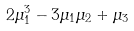Convert formula to latex. <formula><loc_0><loc_0><loc_500><loc_500>2 \mu _ { 1 } ^ { 3 } - 3 \mu _ { 1 } \mu _ { 2 } + \mu _ { 3 }</formula> 